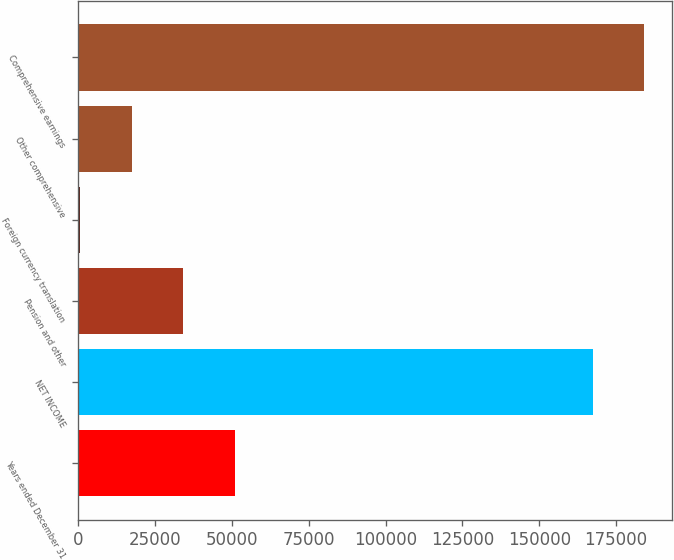Convert chart. <chart><loc_0><loc_0><loc_500><loc_500><bar_chart><fcel>Years ended December 31<fcel>NET INCOME<fcel>Pension and other<fcel>Foreign currency translation<fcel>Other comprehensive<fcel>Comprehensive earnings<nl><fcel>50963<fcel>167369<fcel>34176<fcel>602<fcel>17389<fcel>184156<nl></chart> 